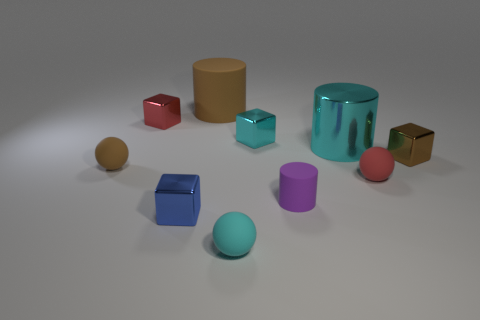Are there any other things that have the same shape as the blue shiny thing?
Give a very brief answer. Yes. What color is the big rubber thing that is the same shape as the large metallic thing?
Give a very brief answer. Brown. Is the blue shiny cube the same size as the brown rubber sphere?
Give a very brief answer. Yes. How many other things are there of the same size as the cyan matte ball?
Keep it short and to the point. 7. What number of things are either small matte spheres in front of the purple thing or small cyan things that are in front of the big cyan shiny object?
Ensure brevity in your answer.  1. What is the shape of the brown metallic thing that is the same size as the red rubber ball?
Keep it short and to the point. Cube. What is the size of the other cylinder that is the same material as the small purple cylinder?
Provide a succinct answer. Large. Does the tiny blue shiny thing have the same shape as the cyan rubber object?
Offer a very short reply. No. There is a thing that is the same size as the shiny cylinder; what is its color?
Give a very brief answer. Brown. What size is the blue object that is the same shape as the tiny cyan metallic thing?
Offer a very short reply. Small. 